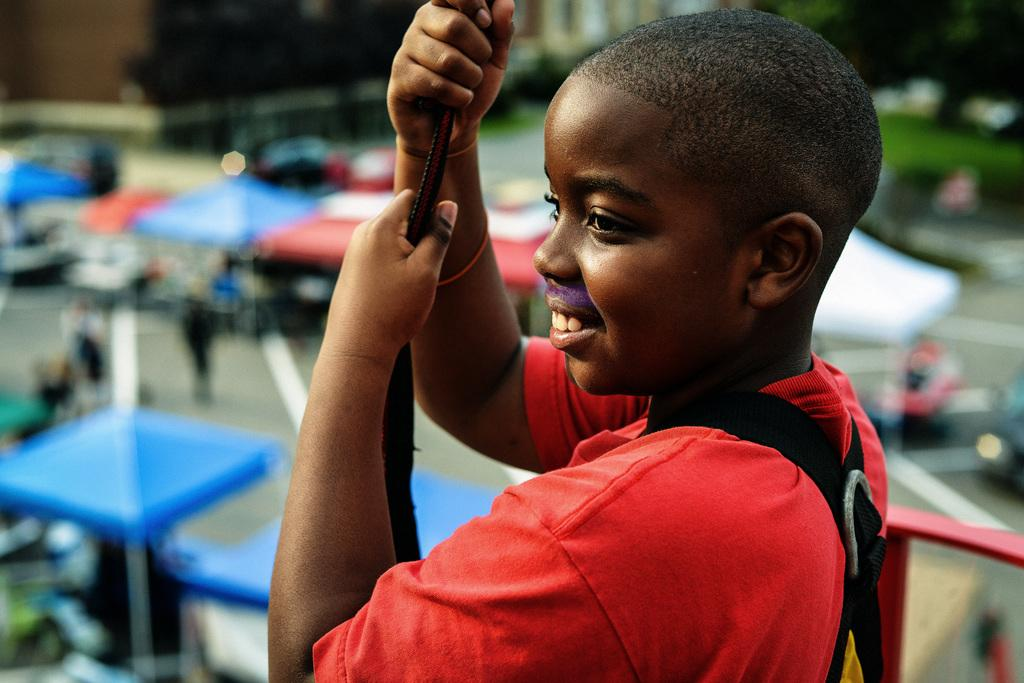What is the main subject of the image? There is a person in the image. What is the person holding in the image? The person is holding a belt with his hands. Can you describe the background of the image? The background of the image is blurred. What objects can be seen in the image besides the person? Umbrellas, a rod, and trees are visible in the image. Are there any other people in the image? Yes, there are people in the image. What type of beast is present in the image? There is no beast present in the image. What type of meeting is taking place in the image? There is no meeting taking place in the image. 